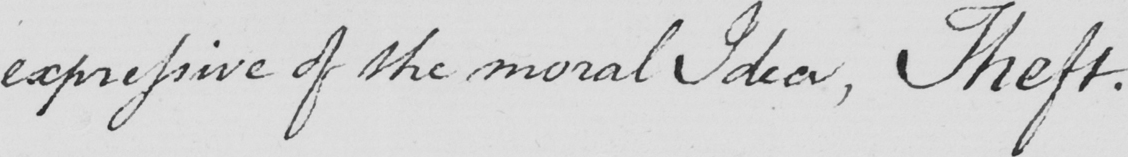What is written in this line of handwriting? expressive of the moral Idea , Theft . 